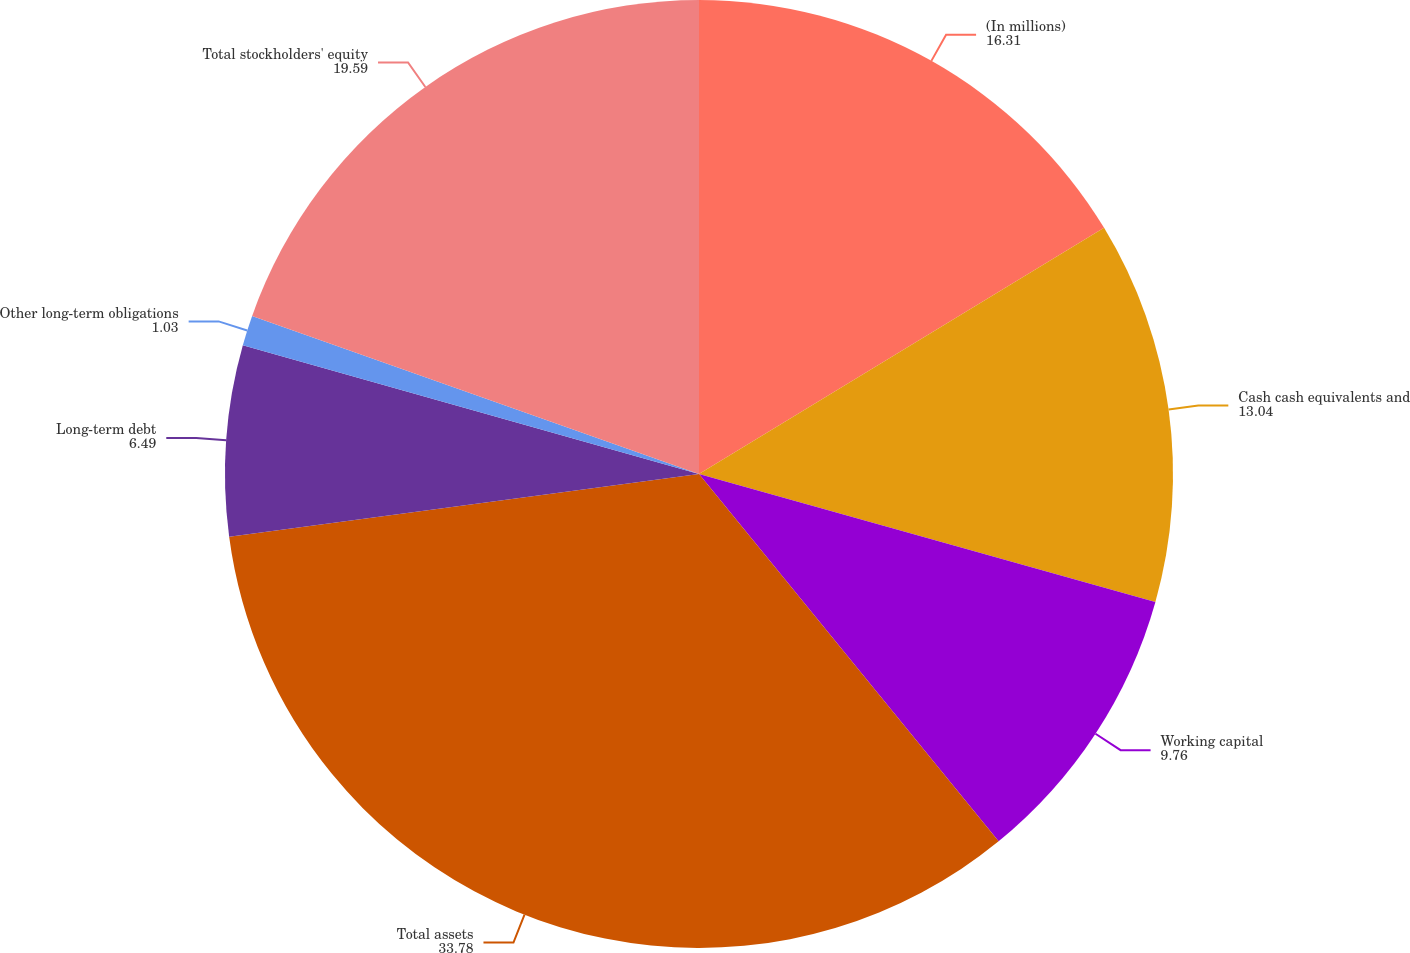Convert chart. <chart><loc_0><loc_0><loc_500><loc_500><pie_chart><fcel>(In millions)<fcel>Cash cash equivalents and<fcel>Working capital<fcel>Total assets<fcel>Long-term debt<fcel>Other long-term obligations<fcel>Total stockholders' equity<nl><fcel>16.31%<fcel>13.04%<fcel>9.76%<fcel>33.78%<fcel>6.49%<fcel>1.03%<fcel>19.59%<nl></chart> 